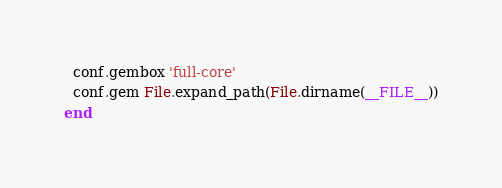Convert code to text. <code><loc_0><loc_0><loc_500><loc_500><_Ruby_>  conf.gembox 'full-core'
  conf.gem File.expand_path(File.dirname(__FILE__))
end
</code> 